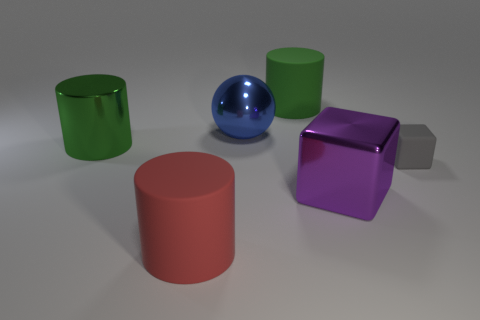What number of big things are purple matte blocks or green shiny cylinders?
Ensure brevity in your answer.  1. The cube that is made of the same material as the big red cylinder is what color?
Provide a short and direct response. Gray. There is a matte thing in front of the tiny gray rubber block; is its shape the same as the green metallic object that is on the left side of the purple thing?
Provide a succinct answer. Yes. What number of rubber objects are large cubes or red things?
Ensure brevity in your answer.  1. What material is the thing that is the same color as the shiny cylinder?
Offer a very short reply. Rubber. Is there any other thing that is the same shape as the green metal thing?
Offer a very short reply. Yes. There is a cube that is left of the tiny gray cube; what is its material?
Provide a short and direct response. Metal. Are the green thing that is to the right of the large metallic ball and the big purple cube made of the same material?
Provide a short and direct response. No. How many objects are either big green metallic things or big metal things in front of the small gray thing?
Your answer should be very brief. 2. What is the size of the other green object that is the same shape as the big green metal thing?
Keep it short and to the point. Large. 